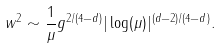Convert formula to latex. <formula><loc_0><loc_0><loc_500><loc_500>w ^ { 2 } \sim \frac { 1 } { \mu } g ^ { 2 / ( 4 - d ) } | \log ( \mu ) | ^ { ( d - 2 ) / ( 4 - d ) } .</formula> 